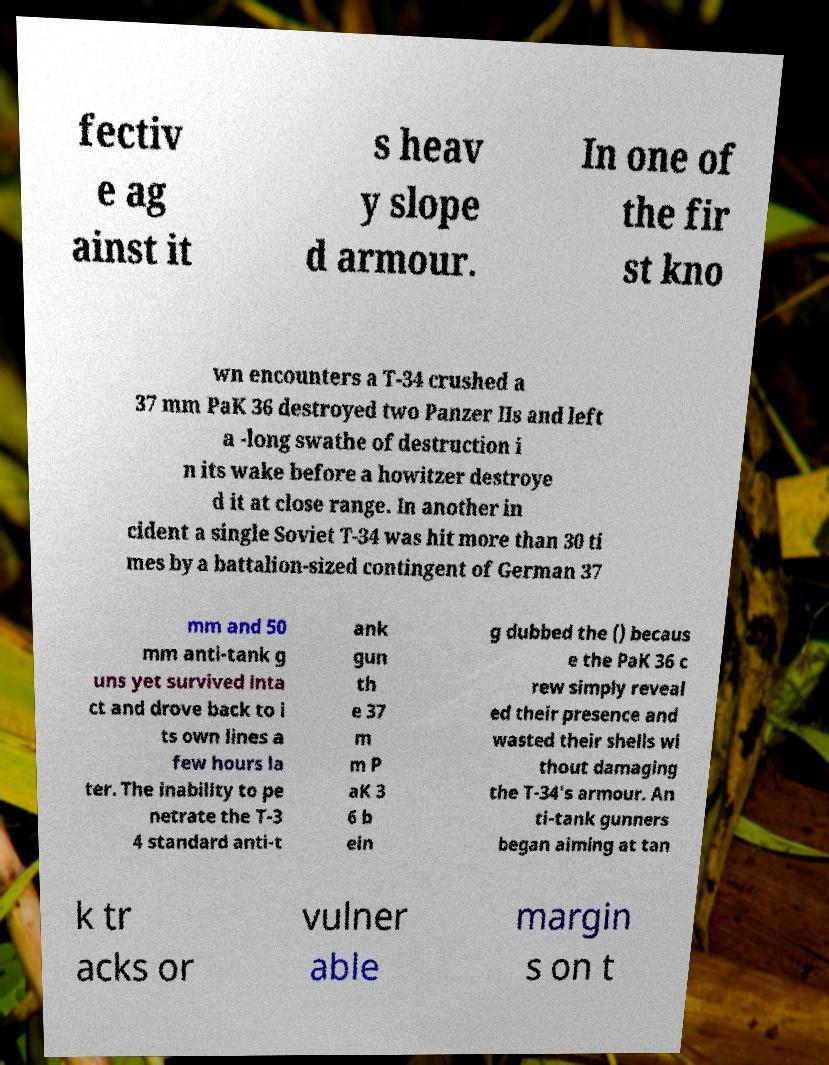There's text embedded in this image that I need extracted. Can you transcribe it verbatim? fectiv e ag ainst it s heav y slope d armour. In one of the fir st kno wn encounters a T-34 crushed a 37 mm PaK 36 destroyed two Panzer IIs and left a -long swathe of destruction i n its wake before a howitzer destroye d it at close range. In another in cident a single Soviet T-34 was hit more than 30 ti mes by a battalion-sized contingent of German 37 mm and 50 mm anti-tank g uns yet survived inta ct and drove back to i ts own lines a few hours la ter. The inability to pe netrate the T-3 4 standard anti-t ank gun th e 37 m m P aK 3 6 b ein g dubbed the () becaus e the PaK 36 c rew simply reveal ed their presence and wasted their shells wi thout damaging the T-34's armour. An ti-tank gunners began aiming at tan k tr acks or vulner able margin s on t 